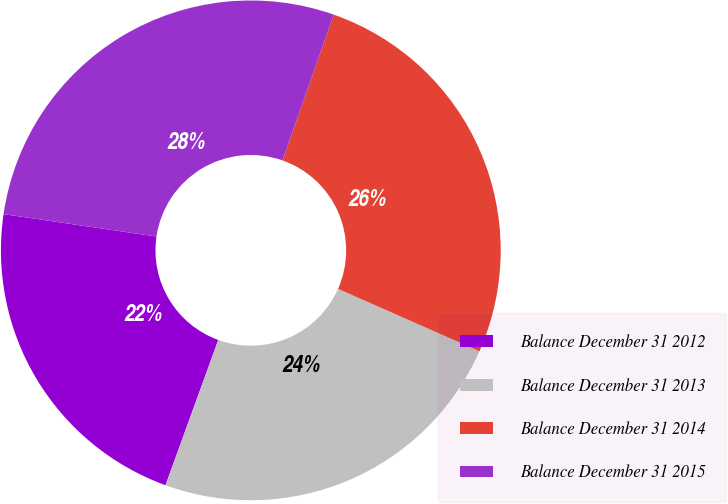<chart> <loc_0><loc_0><loc_500><loc_500><pie_chart><fcel>Balance December 31 2012<fcel>Balance December 31 2013<fcel>Balance December 31 2014<fcel>Balance December 31 2015<nl><fcel>21.77%<fcel>23.93%<fcel>26.23%<fcel>28.07%<nl></chart> 